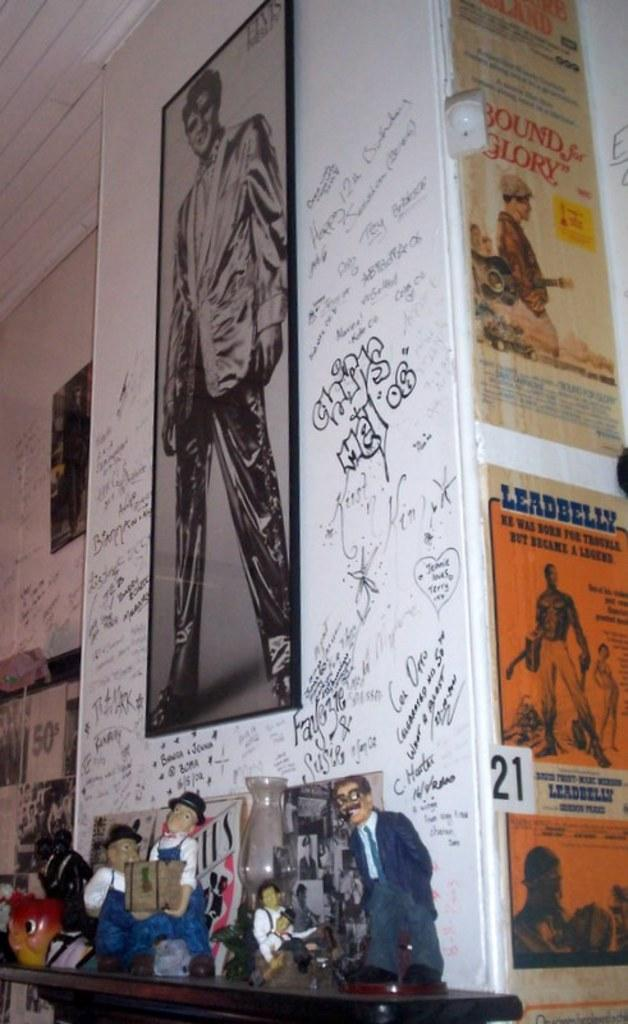<image>
Describe the image concisely. Some posters on the wall such as an orange poster Leadbelly, Yellowish poster of Bound for Glory etc. 